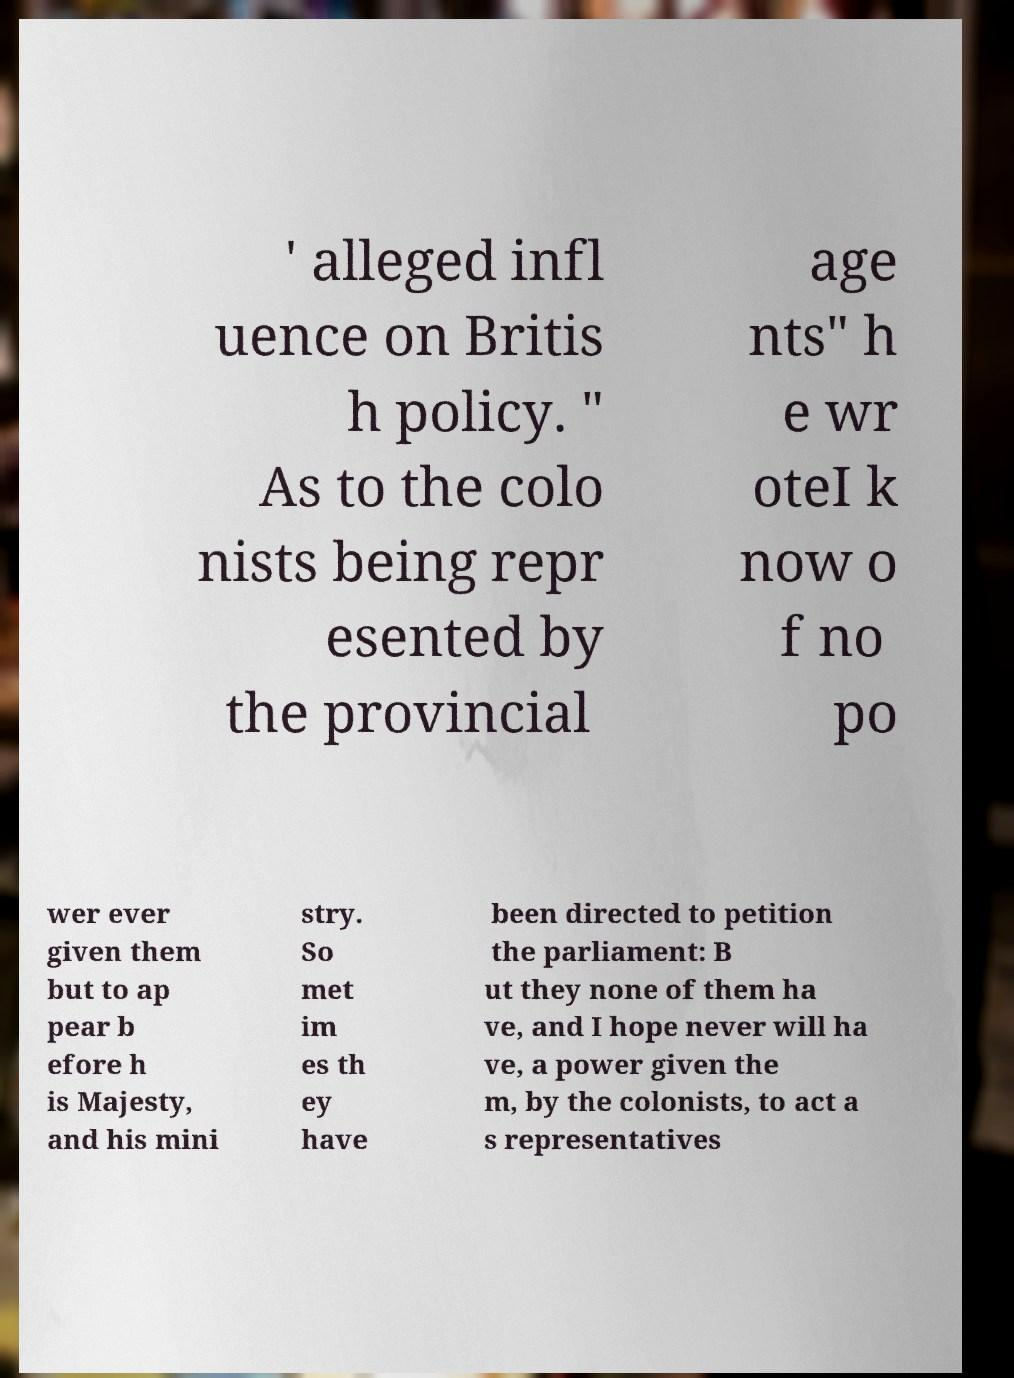Could you extract and type out the text from this image? ' alleged infl uence on Britis h policy. " As to the colo nists being repr esented by the provincial age nts" h e wr oteI k now o f no po wer ever given them but to ap pear b efore h is Majesty, and his mini stry. So met im es th ey have been directed to petition the parliament: B ut they none of them ha ve, and I hope never will ha ve, a power given the m, by the colonists, to act a s representatives 